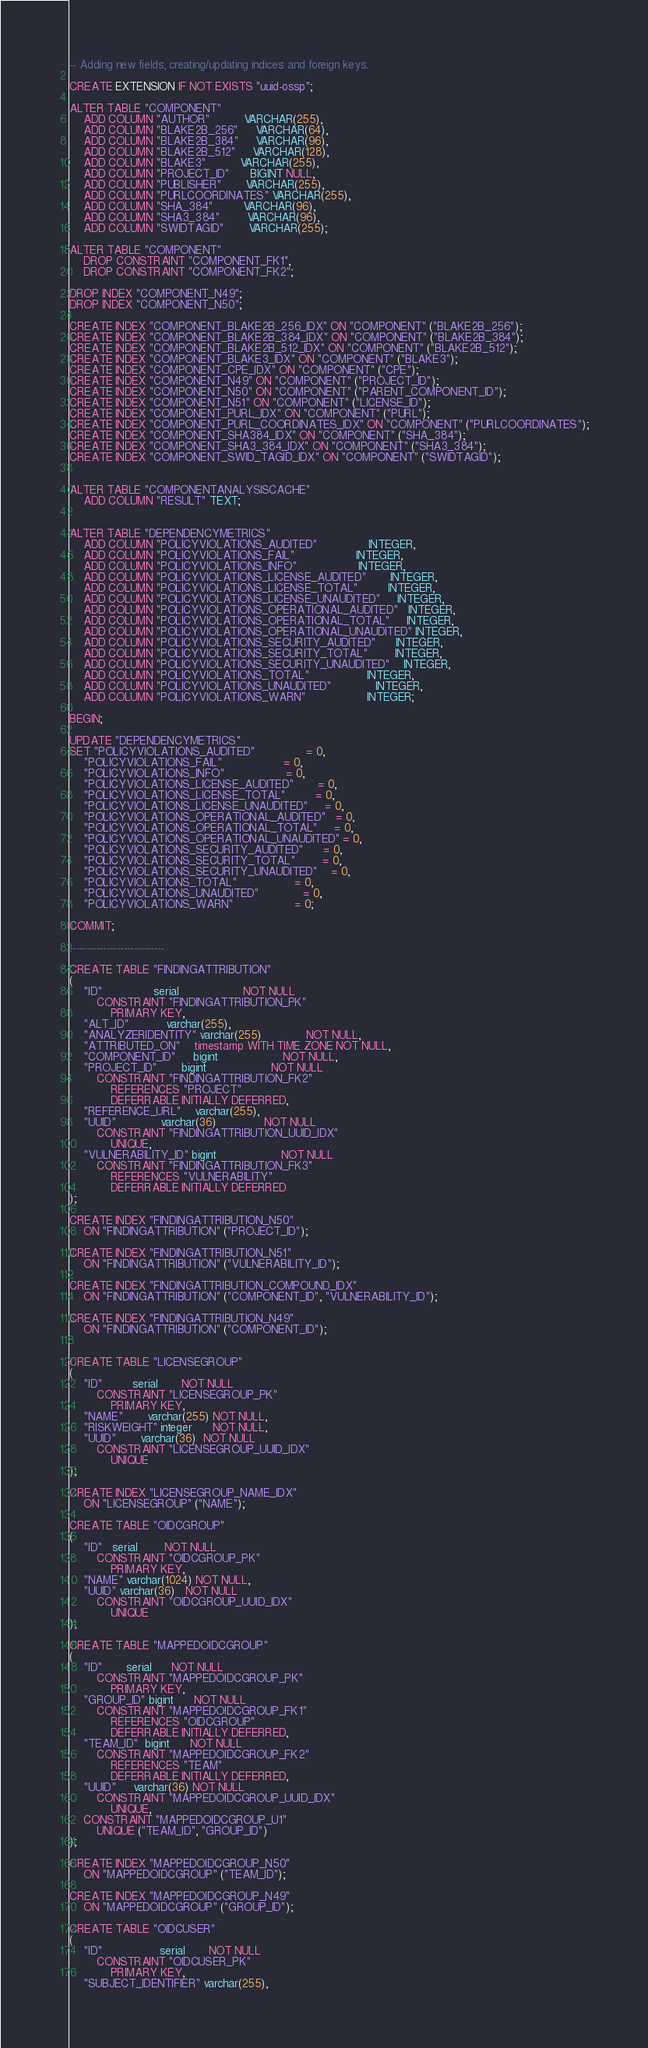Convert code to text. <code><loc_0><loc_0><loc_500><loc_500><_SQL_>-- Adding new fields, creating/updating indices and foreign keys.

CREATE EXTENSION IF NOT EXISTS "uuid-ossp";

ALTER TABLE "COMPONENT"
    ADD COLUMN "AUTHOR"          VARCHAR(255),
    ADD COLUMN "BLAKE2B_256"     VARCHAR(64),
    ADD COLUMN "BLAKE2B_384"     VARCHAR(96),
    ADD COLUMN "BLAKE2B_512"     VARCHAR(128),
    ADD COLUMN "BLAKE3"          VARCHAR(255),
    ADD COLUMN "PROJECT_ID"      BIGINT NULL,
    ADD COLUMN "PUBLISHER"       VARCHAR(255),
    ADD COLUMN "PURLCOORDINATES" VARCHAR(255),
    ADD COLUMN "SHA_384"         VARCHAR(96),
    ADD COLUMN "SHA3_384"        VARCHAR(96),
    ADD COLUMN "SWIDTAGID"       VARCHAR(255);

ALTER TABLE "COMPONENT"
    DROP CONSTRAINT "COMPONENT_FK1",
    DROP CONSTRAINT "COMPONENT_FK2";

DROP INDEX "COMPONENT_N49";
DROP INDEX "COMPONENT_N50";

CREATE INDEX "COMPONENT_BLAKE2B_256_IDX" ON "COMPONENT" ("BLAKE2B_256");
CREATE INDEX "COMPONENT_BLAKE2B_384_IDX" ON "COMPONENT" ("BLAKE2B_384");
CREATE INDEX "COMPONENT_BLAKE2B_512_IDX" ON "COMPONENT" ("BLAKE2B_512");
CREATE INDEX "COMPONENT_BLAKE3_IDX" ON "COMPONENT" ("BLAKE3");
CREATE INDEX "COMPONENT_CPE_IDX" ON "COMPONENT" ("CPE");
CREATE INDEX "COMPONENT_N49" ON "COMPONENT" ("PROJECT_ID");
CREATE INDEX "COMPONENT_N50" ON "COMPONENT" ("PARENT_COMPONENT_ID");
CREATE INDEX "COMPONENT_N51" ON "COMPONENT" ("LICENSE_ID");
CREATE INDEX "COMPONENT_PURL_IDX" ON "COMPONENT" ("PURL");
CREATE INDEX "COMPONENT_PURL_COORDINATES_IDX" ON "COMPONENT" ("PURLCOORDINATES");
CREATE INDEX "COMPONENT_SHA384_IDX" ON "COMPONENT" ("SHA_384");
CREATE INDEX "COMPONENT_SHA3_384_IDX" ON "COMPONENT" ("SHA3_384");
CREATE INDEX "COMPONENT_SWID_TAGID_IDX" ON "COMPONENT" ("SWIDTAGID");


ALTER TABLE "COMPONENTANALYSISCACHE"
    ADD COLUMN "RESULT" TEXT;


ALTER TABLE "DEPENDENCYMETRICS"
    ADD COLUMN "POLICYVIOLATIONS_AUDITED"               INTEGER,
    ADD COLUMN "POLICYVIOLATIONS_FAIL"                  INTEGER,
    ADD COLUMN "POLICYVIOLATIONS_INFO"                  INTEGER,
    ADD COLUMN "POLICYVIOLATIONS_LICENSE_AUDITED"       INTEGER,
    ADD COLUMN "POLICYVIOLATIONS_LICENSE_TOTAL"         INTEGER,
    ADD COLUMN "POLICYVIOLATIONS_LICENSE_UNAUDITED"     INTEGER,
    ADD COLUMN "POLICYVIOLATIONS_OPERATIONAL_AUDITED"   INTEGER,
    ADD COLUMN "POLICYVIOLATIONS_OPERATIONAL_TOTAL"     INTEGER,
    ADD COLUMN "POLICYVIOLATIONS_OPERATIONAL_UNAUDITED" INTEGER,
    ADD COLUMN "POLICYVIOLATIONS_SECURITY_AUDITED"      INTEGER,
    ADD COLUMN "POLICYVIOLATIONS_SECURITY_TOTAL"        INTEGER,
    ADD COLUMN "POLICYVIOLATIONS_SECURITY_UNAUDITED"    INTEGER,
    ADD COLUMN "POLICYVIOLATIONS_TOTAL"                 INTEGER,
    ADD COLUMN "POLICYVIOLATIONS_UNAUDITED"             INTEGER,
    ADD COLUMN "POLICYVIOLATIONS_WARN"                  INTEGER;

BEGIN;

UPDATE "DEPENDENCYMETRICS"
SET "POLICYVIOLATIONS_AUDITED"               = 0,
    "POLICYVIOLATIONS_FAIL"                  = 0,
    "POLICYVIOLATIONS_INFO"                  = 0,
    "POLICYVIOLATIONS_LICENSE_AUDITED"       = 0,
    "POLICYVIOLATIONS_LICENSE_TOTAL"         = 0,
    "POLICYVIOLATIONS_LICENSE_UNAUDITED"     = 0,
    "POLICYVIOLATIONS_OPERATIONAL_AUDITED"   = 0,
    "POLICYVIOLATIONS_OPERATIONAL_TOTAL"     = 0,
    "POLICYVIOLATIONS_OPERATIONAL_UNAUDITED" = 0,
    "POLICYVIOLATIONS_SECURITY_AUDITED"      = 0,
    "POLICYVIOLATIONS_SECURITY_TOTAL"        = 0,
    "POLICYVIOLATIONS_SECURITY_UNAUDITED"    = 0,
    "POLICYVIOLATIONS_TOTAL"                 = 0,
    "POLICYVIOLATIONS_UNAUDITED"             = 0,
    "POLICYVIOLATIONS_WARN"                  = 0;

COMMIT;

----------------------------

CREATE TABLE "FINDINGATTRIBUTION"
(
    "ID"               serial                   NOT NULL
        CONSTRAINT "FINDINGATTRIBUTION_PK"
            PRIMARY KEY,
    "ALT_ID"           varchar(255),
    "ANALYZERIDENTITY" varchar(255)             NOT NULL,
    "ATTRIBUTED_ON"    timestamp WITH TIME ZONE NOT NULL,
    "COMPONENT_ID"     bigint                   NOT NULL,
    "PROJECT_ID"       bigint                   NOT NULL
        CONSTRAINT "FINDINGATTRIBUTION_FK2"
            REFERENCES "PROJECT"
            DEFERRABLE INITIALLY DEFERRED,
    "REFERENCE_URL"    varchar(255),
    "UUID"             varchar(36)              NOT NULL
        CONSTRAINT "FINDINGATTRIBUTION_UUID_IDX"
            UNIQUE,
    "VULNERABILITY_ID" bigint                   NOT NULL
        CONSTRAINT "FINDINGATTRIBUTION_FK3"
            REFERENCES "VULNERABILITY"
            DEFERRABLE INITIALLY DEFERRED
);

CREATE INDEX "FINDINGATTRIBUTION_N50"
    ON "FINDINGATTRIBUTION" ("PROJECT_ID");

CREATE INDEX "FINDINGATTRIBUTION_N51"
    ON "FINDINGATTRIBUTION" ("VULNERABILITY_ID");

CREATE INDEX "FINDINGATTRIBUTION_COMPOUND_IDX"
    ON "FINDINGATTRIBUTION" ("COMPONENT_ID", "VULNERABILITY_ID");

CREATE INDEX "FINDINGATTRIBUTION_N49"
    ON "FINDINGATTRIBUTION" ("COMPONENT_ID");


CREATE TABLE "LICENSEGROUP"
(
    "ID"         serial       NOT NULL
        CONSTRAINT "LICENSEGROUP_PK"
            PRIMARY KEY,
    "NAME"       varchar(255) NOT NULL,
    "RISKWEIGHT" integer      NOT NULL,
    "UUID"       varchar(36)  NOT NULL
        CONSTRAINT "LICENSEGROUP_UUID_IDX"
            UNIQUE
);

CREATE INDEX "LICENSEGROUP_NAME_IDX"
    ON "LICENSEGROUP" ("NAME");

CREATE TABLE "OIDCGROUP"
(
    "ID"   serial        NOT NULL
        CONSTRAINT "OIDCGROUP_PK"
            PRIMARY KEY,
    "NAME" varchar(1024) NOT NULL,
    "UUID" varchar(36)   NOT NULL
        CONSTRAINT "OIDCGROUP_UUID_IDX"
            UNIQUE
);

CREATE TABLE "MAPPEDOIDCGROUP"
(
    "ID"       serial      NOT NULL
        CONSTRAINT "MAPPEDOIDCGROUP_PK"
            PRIMARY KEY,
    "GROUP_ID" bigint      NOT NULL
        CONSTRAINT "MAPPEDOIDCGROUP_FK1"
            REFERENCES "OIDCGROUP"
            DEFERRABLE INITIALLY DEFERRED,
    "TEAM_ID"  bigint      NOT NULL
        CONSTRAINT "MAPPEDOIDCGROUP_FK2"
            REFERENCES "TEAM"
            DEFERRABLE INITIALLY DEFERRED,
    "UUID"     varchar(36) NOT NULL
        CONSTRAINT "MAPPEDOIDCGROUP_UUID_IDX"
            UNIQUE,
    CONSTRAINT "MAPPEDOIDCGROUP_U1"
        UNIQUE ("TEAM_ID", "GROUP_ID")
);

CREATE INDEX "MAPPEDOIDCGROUP_N50"
    ON "MAPPEDOIDCGROUP" ("TEAM_ID");

CREATE INDEX "MAPPEDOIDCGROUP_N49"
    ON "MAPPEDOIDCGROUP" ("GROUP_ID");

CREATE TABLE "OIDCUSER"
(
    "ID"                 serial       NOT NULL
        CONSTRAINT "OIDCUSER_PK"
            PRIMARY KEY,
    "SUBJECT_IDENTIFIER" varchar(255),</code> 